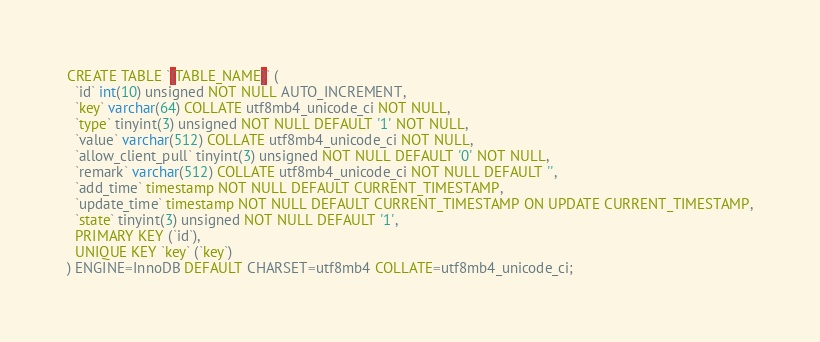<code> <loc_0><loc_0><loc_500><loc_500><_SQL_>CREATE TABLE `{TABLE_NAME}` (
  `id` int(10) unsigned NOT NULL AUTO_INCREMENT,
  `key` varchar(64) COLLATE utf8mb4_unicode_ci NOT NULL,
  `type` tinyint(3) unsigned NOT NULL DEFAULT '1' NOT NULL,
  `value` varchar(512) COLLATE utf8mb4_unicode_ci NOT NULL,
  `allow_client_pull` tinyint(3) unsigned NOT NULL DEFAULT '0' NOT NULL,
  `remark` varchar(512) COLLATE utf8mb4_unicode_ci NOT NULL DEFAULT '',
  `add_time` timestamp NOT NULL DEFAULT CURRENT_TIMESTAMP,
  `update_time` timestamp NOT NULL DEFAULT CURRENT_TIMESTAMP ON UPDATE CURRENT_TIMESTAMP,
  `state` tinyint(3) unsigned NOT NULL DEFAULT '1',
  PRIMARY KEY (`id`),
  UNIQUE KEY `key` (`key`)
) ENGINE=InnoDB DEFAULT CHARSET=utf8mb4 COLLATE=utf8mb4_unicode_ci;
</code> 